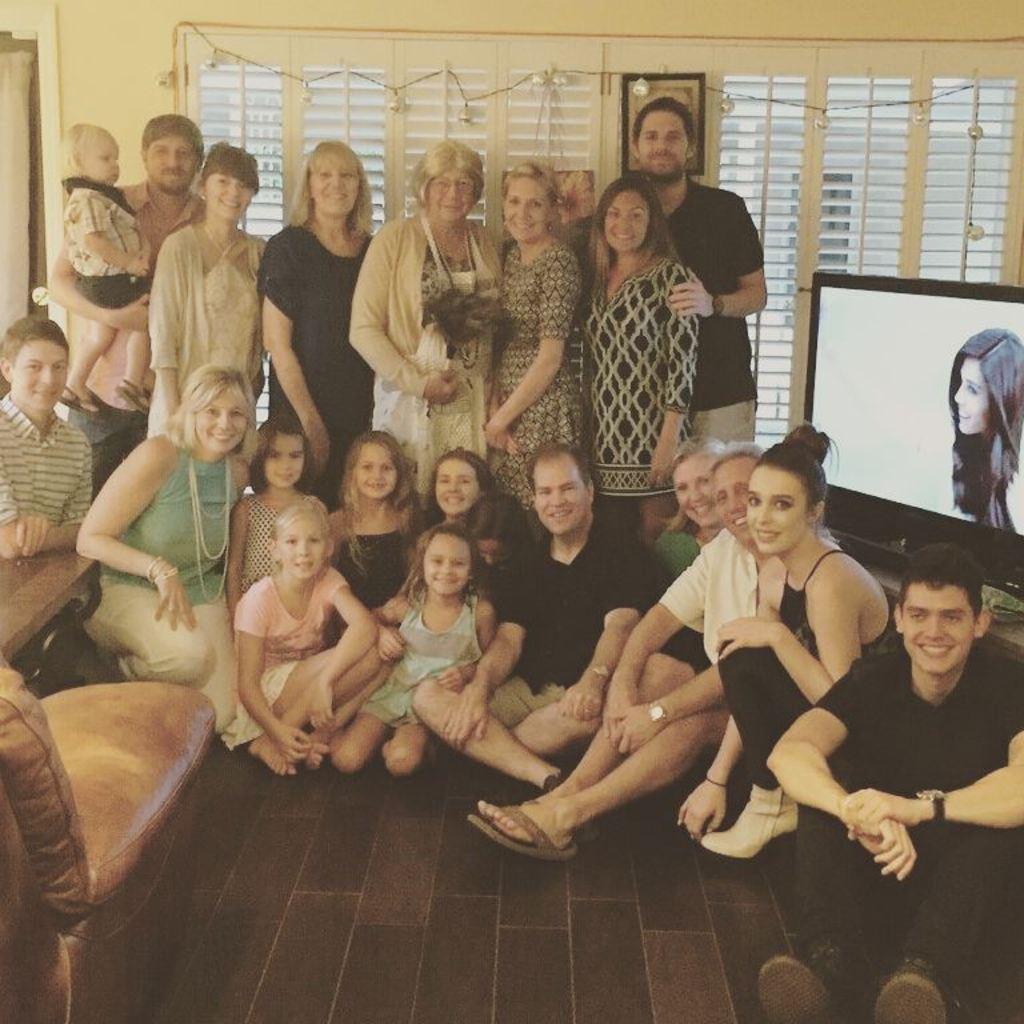Could you give a brief overview of what you see in this image? There are many people. Some are sitting and some are standing. Lady in the center is holding something in the hand. On the left side there is a sofa. On the right side there is a television. In the back there are windows. 